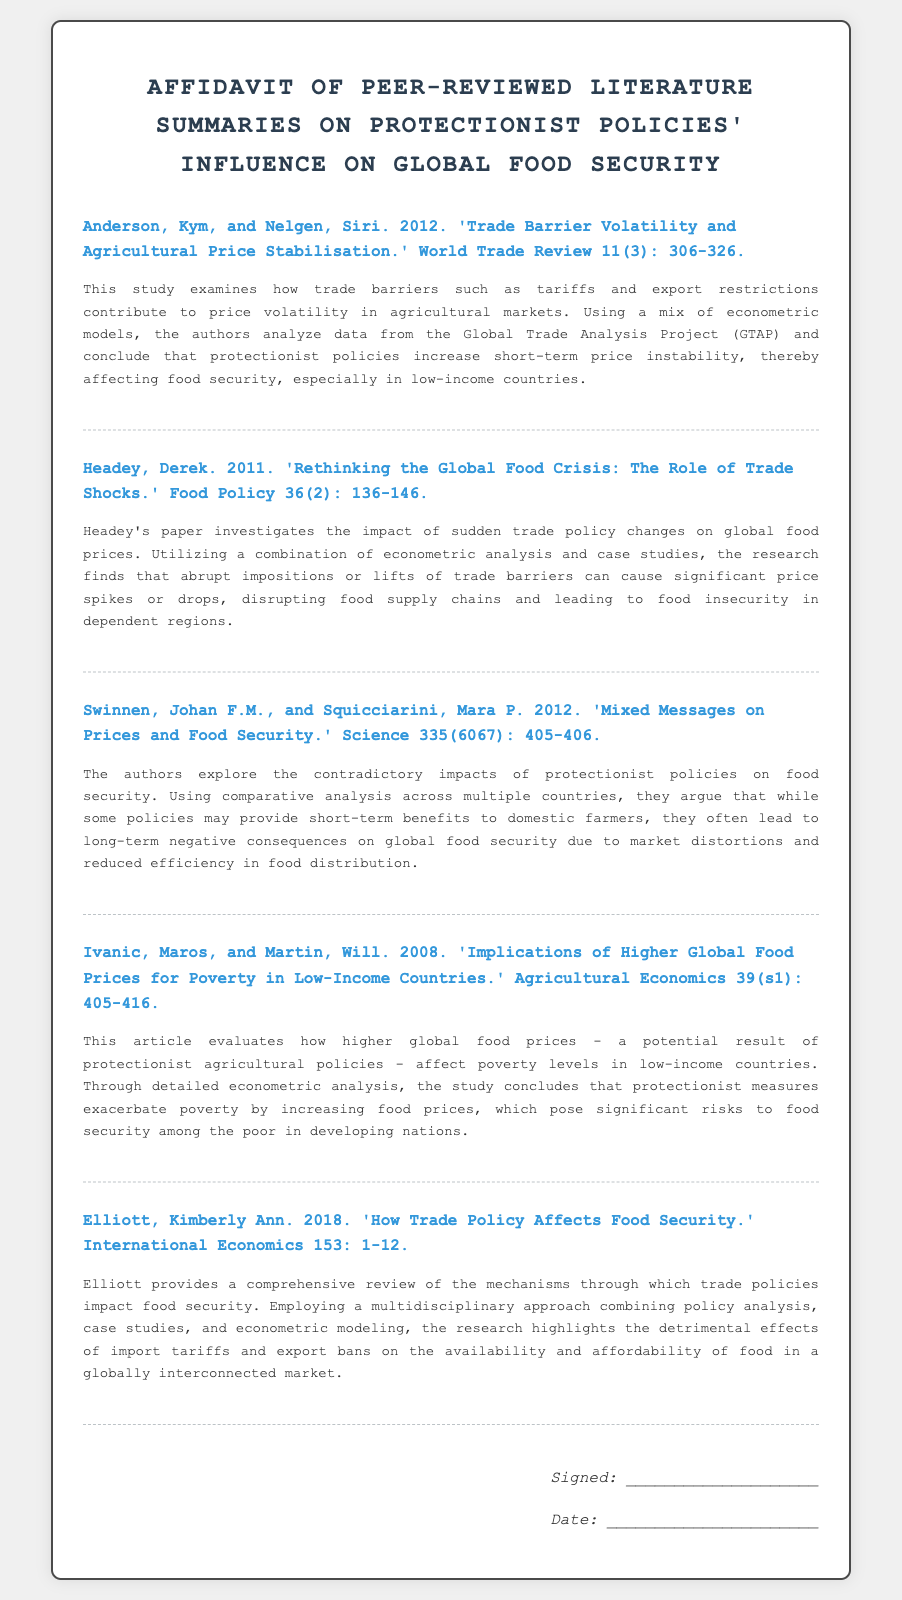What is the title of the affidavit? The title of the affidavit is prominently stated at the top of the document.
Answer: Affidavit of Peer-Reviewed Literature Summaries on Protectionist Policies' Influence on Global Food Security Who are the authors of the first study? The first study's authors are listed in the reference section of the document.
Answer: Anderson, Kym, and Nelgen, Siri What year was Headey's paper published? The publication year is indicated in the reference section of the document.
Answer: 2011 What is the main focus of Elliott's 2018 paper? The summary of Elliott's paper provides insight into its main focus.
Answer: How Trade Policy Affects Food Security Which study discusses poverty levels in low-income countries? The specific study that evaluates poverty levels is detailed in the document.
Answer: Ivanic, Maros, and Martin, 2008 How do protectionist policies affect food prices according to the document? The document summarizes findings on the relationship between protectionist policies and food prices.
Answer: Increase food prices What methodology is commonly used in the studies cited? The document often refers to the methodologies employed in the studies described.
Answer: Econometric analysis What negative consequence is mentioned regarding protectionist measures? The summaries include various negative impacts of protectionist measures.
Answer: Exacerbate poverty What type of document is this? The content and structure indicate the type of document presented.
Answer: Affidavit 